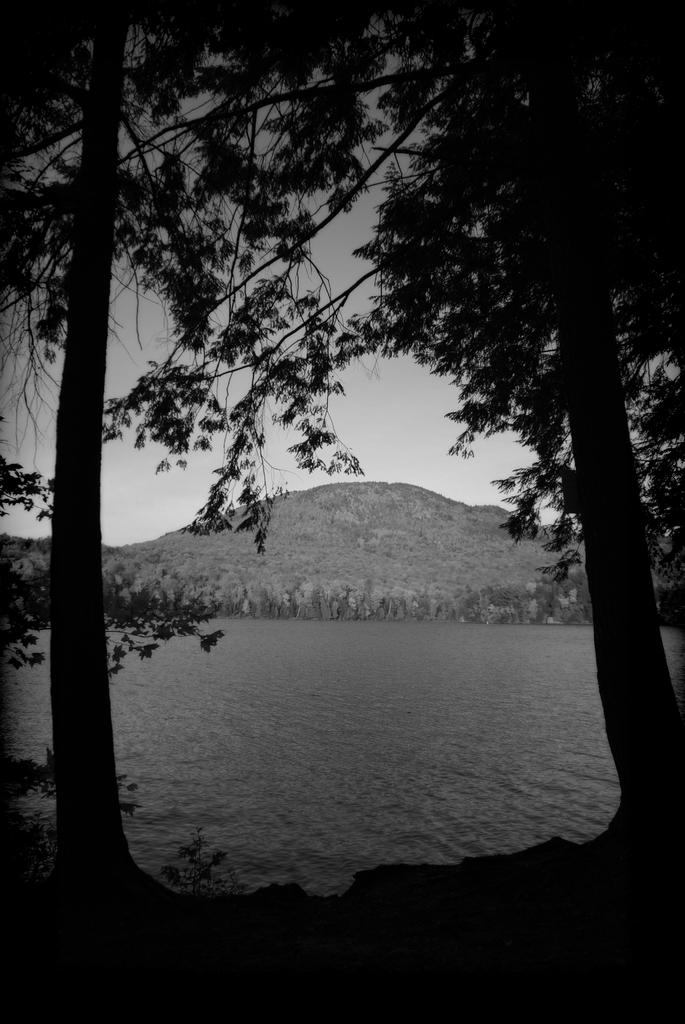What is the color scheme of the image? The image is black and white. What type of natural elements can be seen in the image? There are trees and water visible in the image. What kind of landscape feature is present in the image? There is a hill in the image. What part of the natural environment is visible in the image? The sky is visible in the image. How many quivers can be seen in the image? There are no quivers present in the image. What type of queen is depicted in the image? There is no queen depicted in the image. 